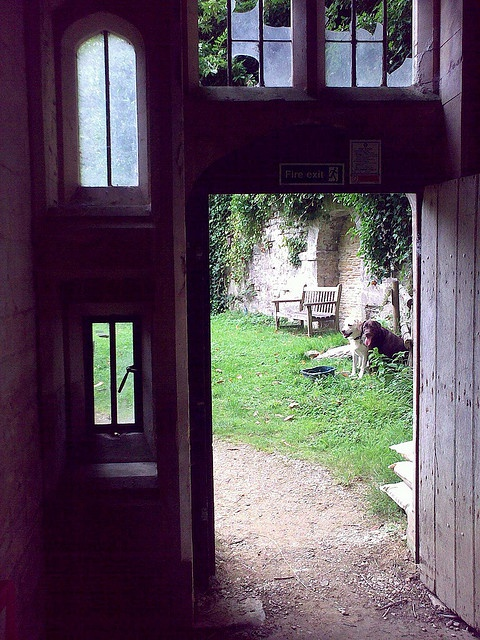Describe the objects in this image and their specific colors. I can see bench in black, white, gray, and darkgray tones, dog in black, purple, gray, and darkgray tones, dog in black, white, darkgray, and gray tones, and bowl in black, gray, lightgray, and navy tones in this image. 